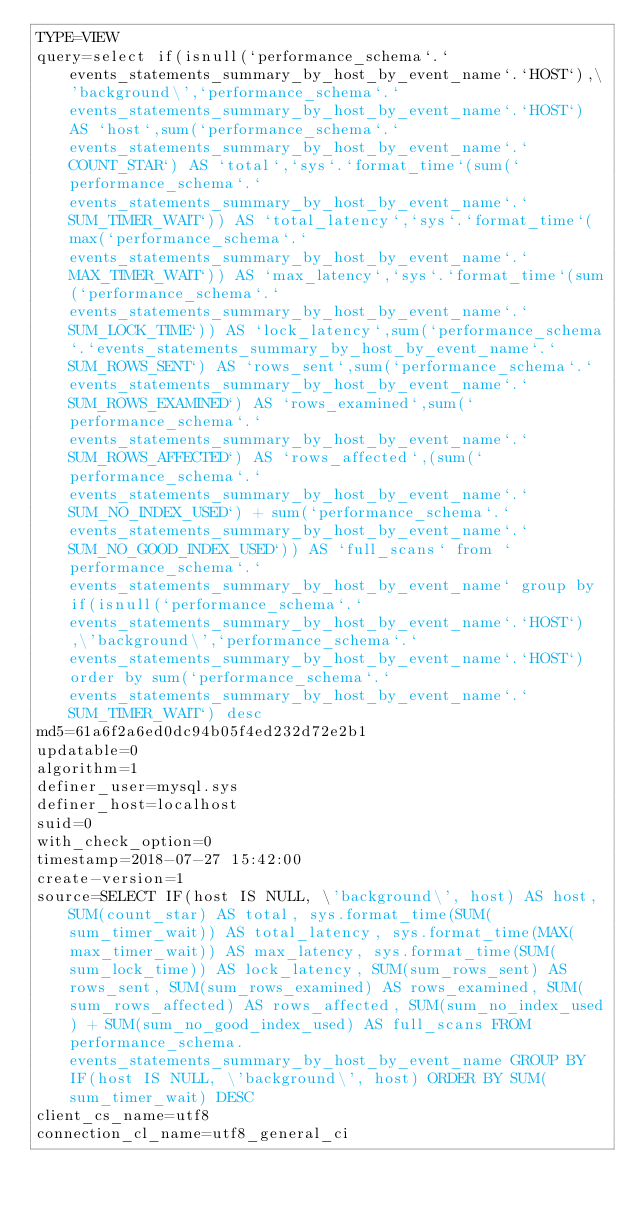<code> <loc_0><loc_0><loc_500><loc_500><_VisualBasic_>TYPE=VIEW
query=select if(isnull(`performance_schema`.`events_statements_summary_by_host_by_event_name`.`HOST`),\'background\',`performance_schema`.`events_statements_summary_by_host_by_event_name`.`HOST`) AS `host`,sum(`performance_schema`.`events_statements_summary_by_host_by_event_name`.`COUNT_STAR`) AS `total`,`sys`.`format_time`(sum(`performance_schema`.`events_statements_summary_by_host_by_event_name`.`SUM_TIMER_WAIT`)) AS `total_latency`,`sys`.`format_time`(max(`performance_schema`.`events_statements_summary_by_host_by_event_name`.`MAX_TIMER_WAIT`)) AS `max_latency`,`sys`.`format_time`(sum(`performance_schema`.`events_statements_summary_by_host_by_event_name`.`SUM_LOCK_TIME`)) AS `lock_latency`,sum(`performance_schema`.`events_statements_summary_by_host_by_event_name`.`SUM_ROWS_SENT`) AS `rows_sent`,sum(`performance_schema`.`events_statements_summary_by_host_by_event_name`.`SUM_ROWS_EXAMINED`) AS `rows_examined`,sum(`performance_schema`.`events_statements_summary_by_host_by_event_name`.`SUM_ROWS_AFFECTED`) AS `rows_affected`,(sum(`performance_schema`.`events_statements_summary_by_host_by_event_name`.`SUM_NO_INDEX_USED`) + sum(`performance_schema`.`events_statements_summary_by_host_by_event_name`.`SUM_NO_GOOD_INDEX_USED`)) AS `full_scans` from `performance_schema`.`events_statements_summary_by_host_by_event_name` group by if(isnull(`performance_schema`.`events_statements_summary_by_host_by_event_name`.`HOST`),\'background\',`performance_schema`.`events_statements_summary_by_host_by_event_name`.`HOST`) order by sum(`performance_schema`.`events_statements_summary_by_host_by_event_name`.`SUM_TIMER_WAIT`) desc
md5=61a6f2a6ed0dc94b05f4ed232d72e2b1
updatable=0
algorithm=1
definer_user=mysql.sys
definer_host=localhost
suid=0
with_check_option=0
timestamp=2018-07-27 15:42:00
create-version=1
source=SELECT IF(host IS NULL, \'background\', host) AS host, SUM(count_star) AS total, sys.format_time(SUM(sum_timer_wait)) AS total_latency, sys.format_time(MAX(max_timer_wait)) AS max_latency, sys.format_time(SUM(sum_lock_time)) AS lock_latency, SUM(sum_rows_sent) AS rows_sent, SUM(sum_rows_examined) AS rows_examined, SUM(sum_rows_affected) AS rows_affected, SUM(sum_no_index_used) + SUM(sum_no_good_index_used) AS full_scans FROM performance_schema.events_statements_summary_by_host_by_event_name GROUP BY IF(host IS NULL, \'background\', host) ORDER BY SUM(sum_timer_wait) DESC
client_cs_name=utf8
connection_cl_name=utf8_general_ci</code> 